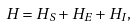Convert formula to latex. <formula><loc_0><loc_0><loc_500><loc_500>H = H _ { S } + H _ { E } + H _ { I } ,</formula> 